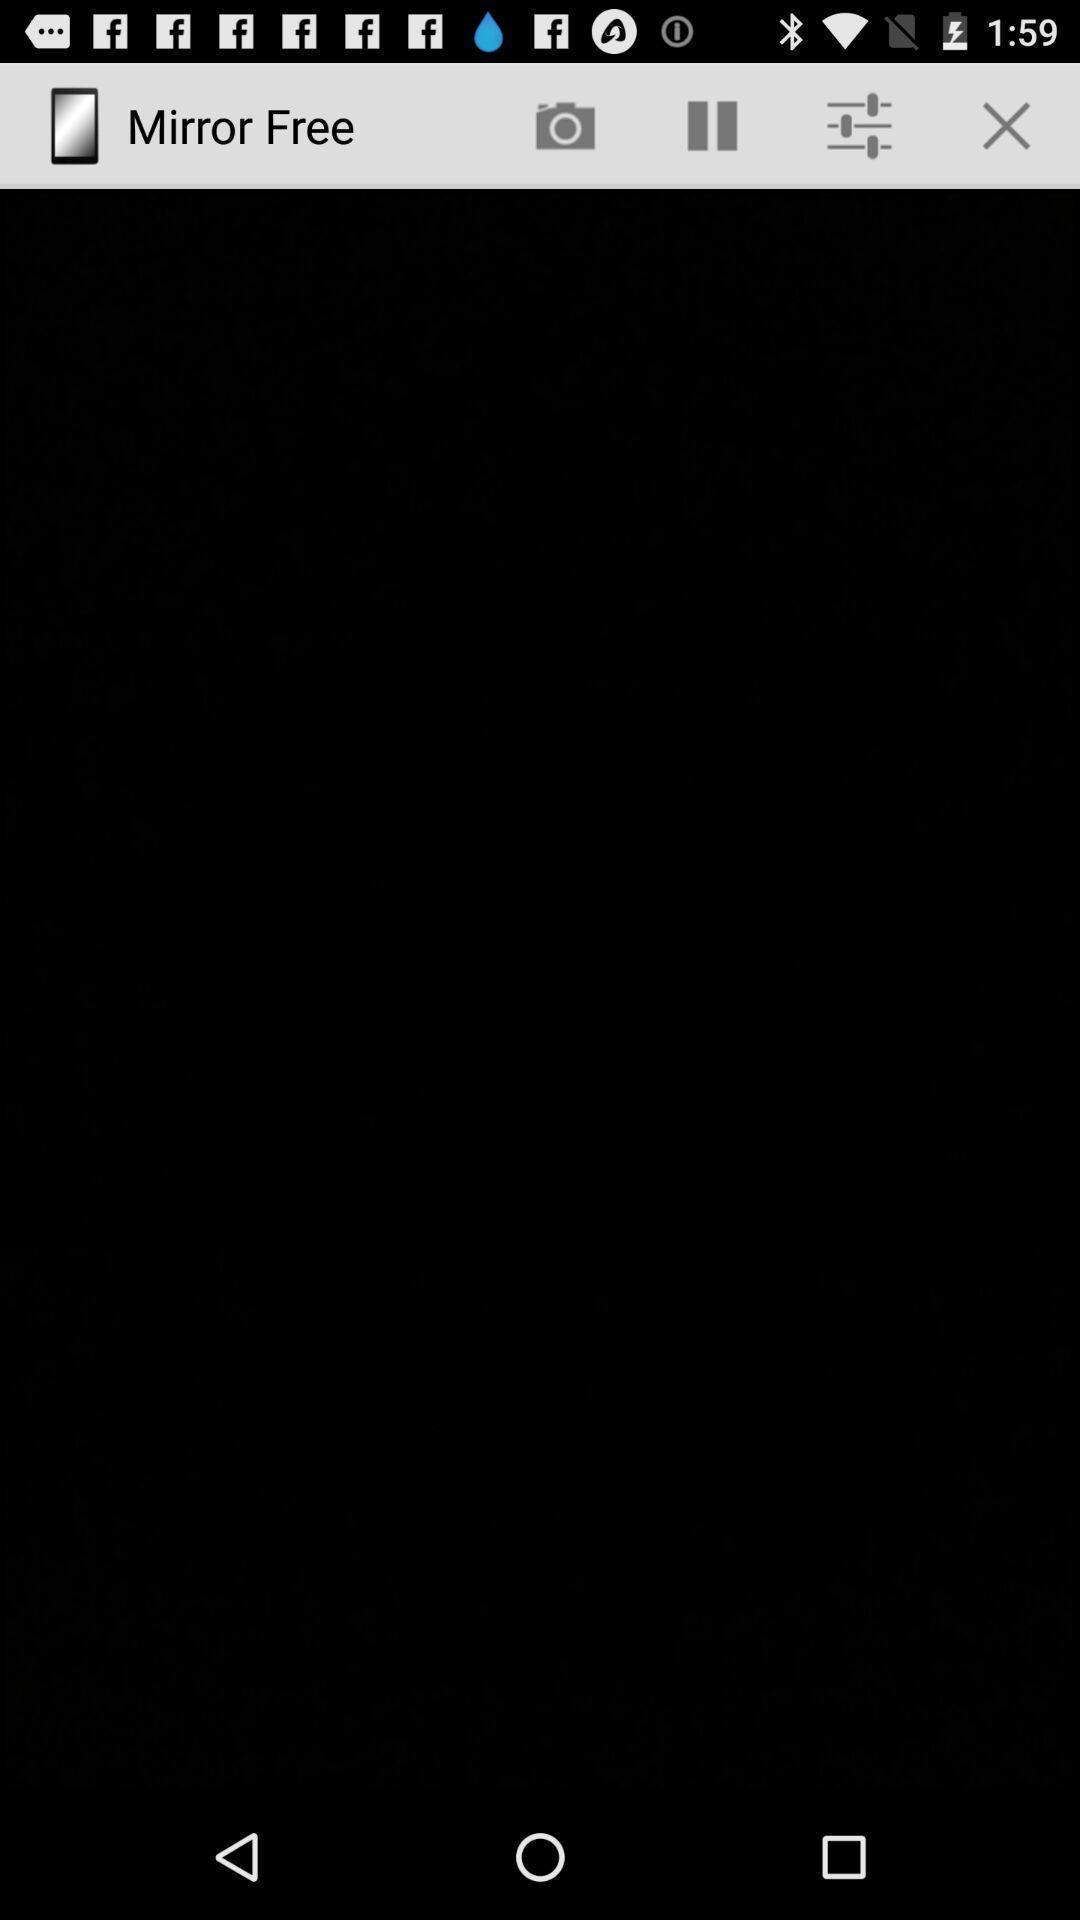Provide a detailed account of this screenshot. Screen displaying blank page for an application. 